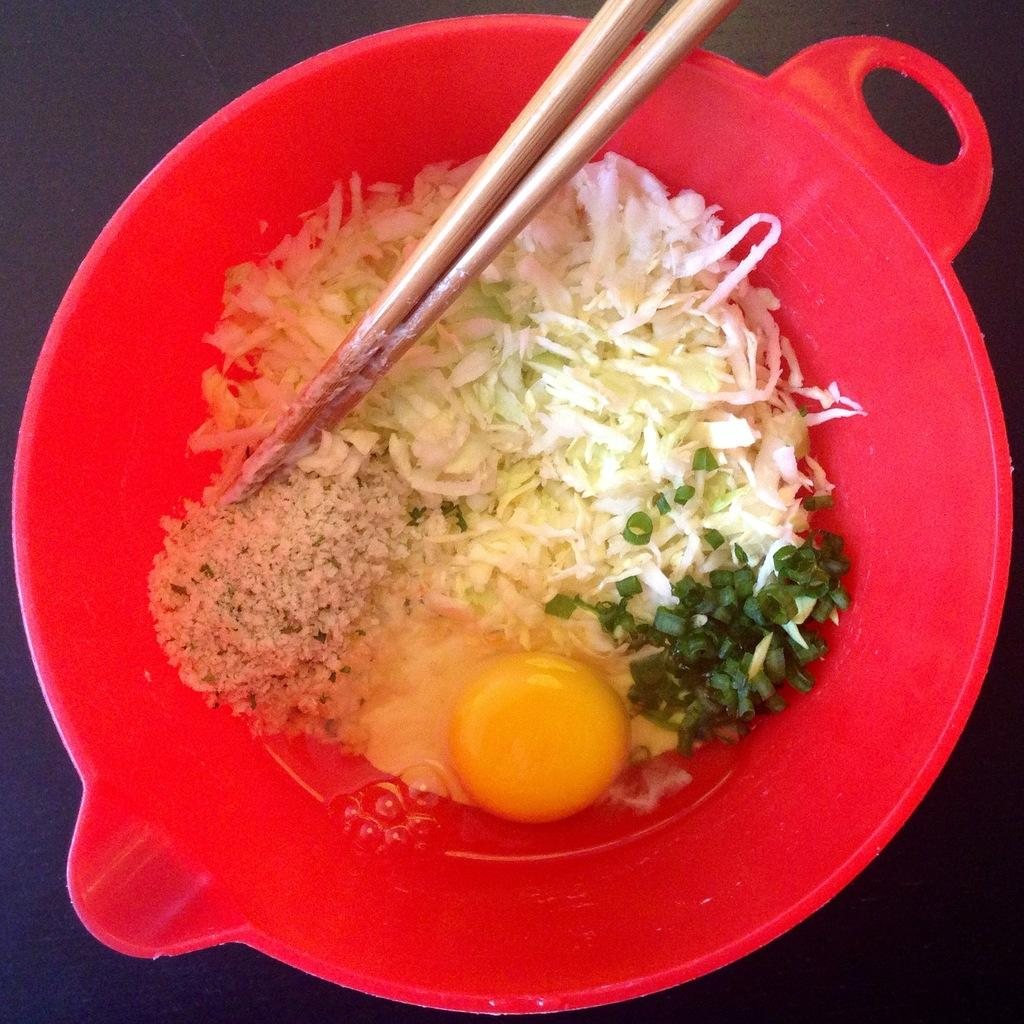What color is the bowl in the image? The bowl in the image is red. What is inside the red bowl? The red bowl contains an egg yolk. What utensil is present in the image? Chopsticks are present in the image. What type of pancake is being prepared by the actor in the image? There is no pancake or actor present in the image; it features a red bowl with an egg yolk and chopsticks. What instrument is the drum being played by the chef in the image? There is no drum or chef present in the image. 